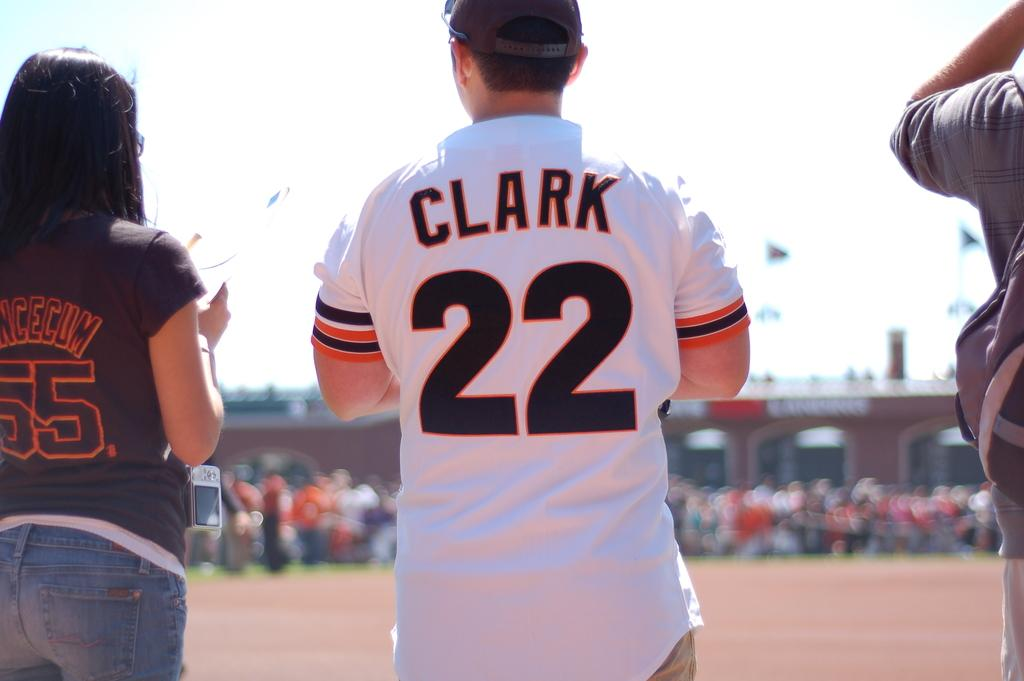<image>
Present a compact description of the photo's key features. Someone with their back to the camera is wearing a number 22 on their shirt. 